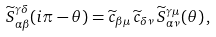Convert formula to latex. <formula><loc_0><loc_0><loc_500><loc_500>\widetilde { S } ^ { \gamma \delta } _ { \alpha \beta } ( i \pi - \theta ) = \widetilde { c } _ { \beta \mu } \, \widetilde { c } _ { \delta \nu } \, \widetilde { S } ^ { \gamma \mu } _ { \alpha \nu } ( \theta ) \, ,</formula> 